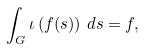<formula> <loc_0><loc_0><loc_500><loc_500>\int _ { G } \iota \left ( f ( s ) \right ) \, d s = f ,</formula> 